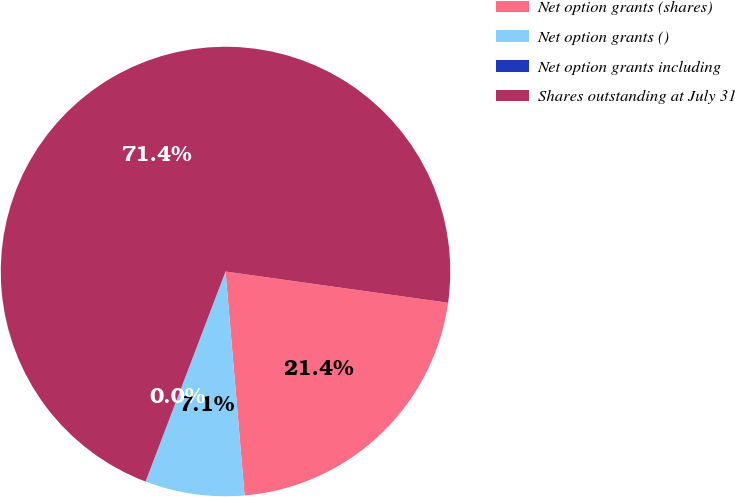Convert chart. <chart><loc_0><loc_0><loc_500><loc_500><pie_chart><fcel>Net option grants (shares)<fcel>Net option grants ()<fcel>Net option grants including<fcel>Shares outstanding at July 31<nl><fcel>21.43%<fcel>7.14%<fcel>0.0%<fcel>71.43%<nl></chart> 